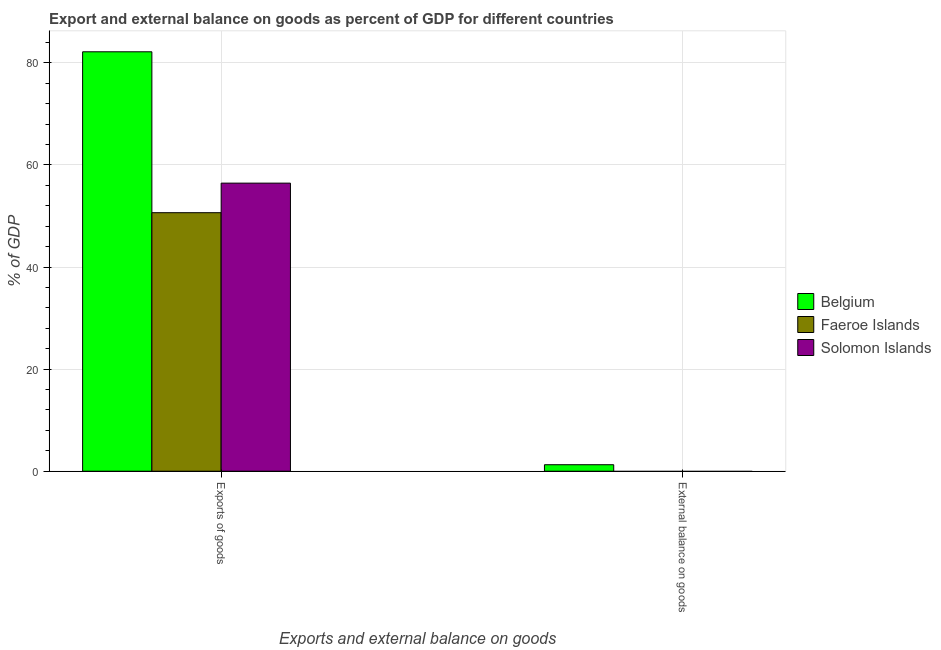How many different coloured bars are there?
Your answer should be very brief. 3. Are the number of bars per tick equal to the number of legend labels?
Make the answer very short. No. How many bars are there on the 1st tick from the left?
Offer a terse response. 3. What is the label of the 1st group of bars from the left?
Your answer should be very brief. Exports of goods. What is the export of goods as percentage of gdp in Faeroe Islands?
Your answer should be compact. 50.64. Across all countries, what is the maximum export of goods as percentage of gdp?
Your answer should be compact. 82.16. Across all countries, what is the minimum export of goods as percentage of gdp?
Your answer should be compact. 50.64. What is the total external balance on goods as percentage of gdp in the graph?
Offer a terse response. 1.27. What is the difference between the export of goods as percentage of gdp in Belgium and that in Faeroe Islands?
Keep it short and to the point. 31.52. What is the difference between the external balance on goods as percentage of gdp in Belgium and the export of goods as percentage of gdp in Faeroe Islands?
Your response must be concise. -49.37. What is the average external balance on goods as percentage of gdp per country?
Your answer should be very brief. 0.42. What is the difference between the external balance on goods as percentage of gdp and export of goods as percentage of gdp in Belgium?
Your answer should be very brief. -80.88. In how many countries, is the external balance on goods as percentage of gdp greater than 28 %?
Your answer should be very brief. 0. What is the ratio of the export of goods as percentage of gdp in Solomon Islands to that in Belgium?
Provide a succinct answer. 0.69. In how many countries, is the export of goods as percentage of gdp greater than the average export of goods as percentage of gdp taken over all countries?
Offer a terse response. 1. How many bars are there?
Make the answer very short. 4. Are all the bars in the graph horizontal?
Your answer should be compact. No. Are the values on the major ticks of Y-axis written in scientific E-notation?
Keep it short and to the point. No. How are the legend labels stacked?
Your response must be concise. Vertical. What is the title of the graph?
Make the answer very short. Export and external balance on goods as percent of GDP for different countries. Does "OECD members" appear as one of the legend labels in the graph?
Keep it short and to the point. No. What is the label or title of the X-axis?
Provide a succinct answer. Exports and external balance on goods. What is the label or title of the Y-axis?
Keep it short and to the point. % of GDP. What is the % of GDP of Belgium in Exports of goods?
Make the answer very short. 82.16. What is the % of GDP of Faeroe Islands in Exports of goods?
Your answer should be very brief. 50.64. What is the % of GDP in Solomon Islands in Exports of goods?
Provide a short and direct response. 56.43. What is the % of GDP in Belgium in External balance on goods?
Offer a terse response. 1.27. Across all Exports and external balance on goods, what is the maximum % of GDP in Belgium?
Make the answer very short. 82.16. Across all Exports and external balance on goods, what is the maximum % of GDP of Faeroe Islands?
Your answer should be very brief. 50.64. Across all Exports and external balance on goods, what is the maximum % of GDP of Solomon Islands?
Make the answer very short. 56.43. Across all Exports and external balance on goods, what is the minimum % of GDP of Belgium?
Offer a terse response. 1.27. What is the total % of GDP in Belgium in the graph?
Ensure brevity in your answer.  83.43. What is the total % of GDP in Faeroe Islands in the graph?
Give a very brief answer. 50.64. What is the total % of GDP in Solomon Islands in the graph?
Your answer should be compact. 56.43. What is the difference between the % of GDP of Belgium in Exports of goods and that in External balance on goods?
Offer a terse response. 80.88. What is the average % of GDP of Belgium per Exports and external balance on goods?
Offer a terse response. 41.72. What is the average % of GDP in Faeroe Islands per Exports and external balance on goods?
Your answer should be compact. 25.32. What is the average % of GDP of Solomon Islands per Exports and external balance on goods?
Give a very brief answer. 28.22. What is the difference between the % of GDP of Belgium and % of GDP of Faeroe Islands in Exports of goods?
Offer a very short reply. 31.52. What is the difference between the % of GDP of Belgium and % of GDP of Solomon Islands in Exports of goods?
Ensure brevity in your answer.  25.73. What is the difference between the % of GDP in Faeroe Islands and % of GDP in Solomon Islands in Exports of goods?
Your answer should be very brief. -5.79. What is the ratio of the % of GDP of Belgium in Exports of goods to that in External balance on goods?
Ensure brevity in your answer.  64.51. What is the difference between the highest and the second highest % of GDP in Belgium?
Provide a short and direct response. 80.88. What is the difference between the highest and the lowest % of GDP of Belgium?
Offer a terse response. 80.88. What is the difference between the highest and the lowest % of GDP of Faeroe Islands?
Give a very brief answer. 50.64. What is the difference between the highest and the lowest % of GDP in Solomon Islands?
Ensure brevity in your answer.  56.43. 